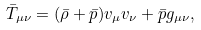Convert formula to latex. <formula><loc_0><loc_0><loc_500><loc_500>\bar { T } _ { \mu \nu } = ( \bar { \rho } + \bar { p } ) v _ { \mu } v _ { \nu } + \bar { p } g _ { \mu \nu } ,</formula> 